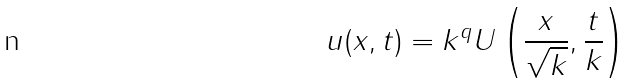Convert formula to latex. <formula><loc_0><loc_0><loc_500><loc_500>u ( x , t ) = k ^ { q } U \left ( \frac { x } { \sqrt { k } } , \frac { t } { k } \right )</formula> 